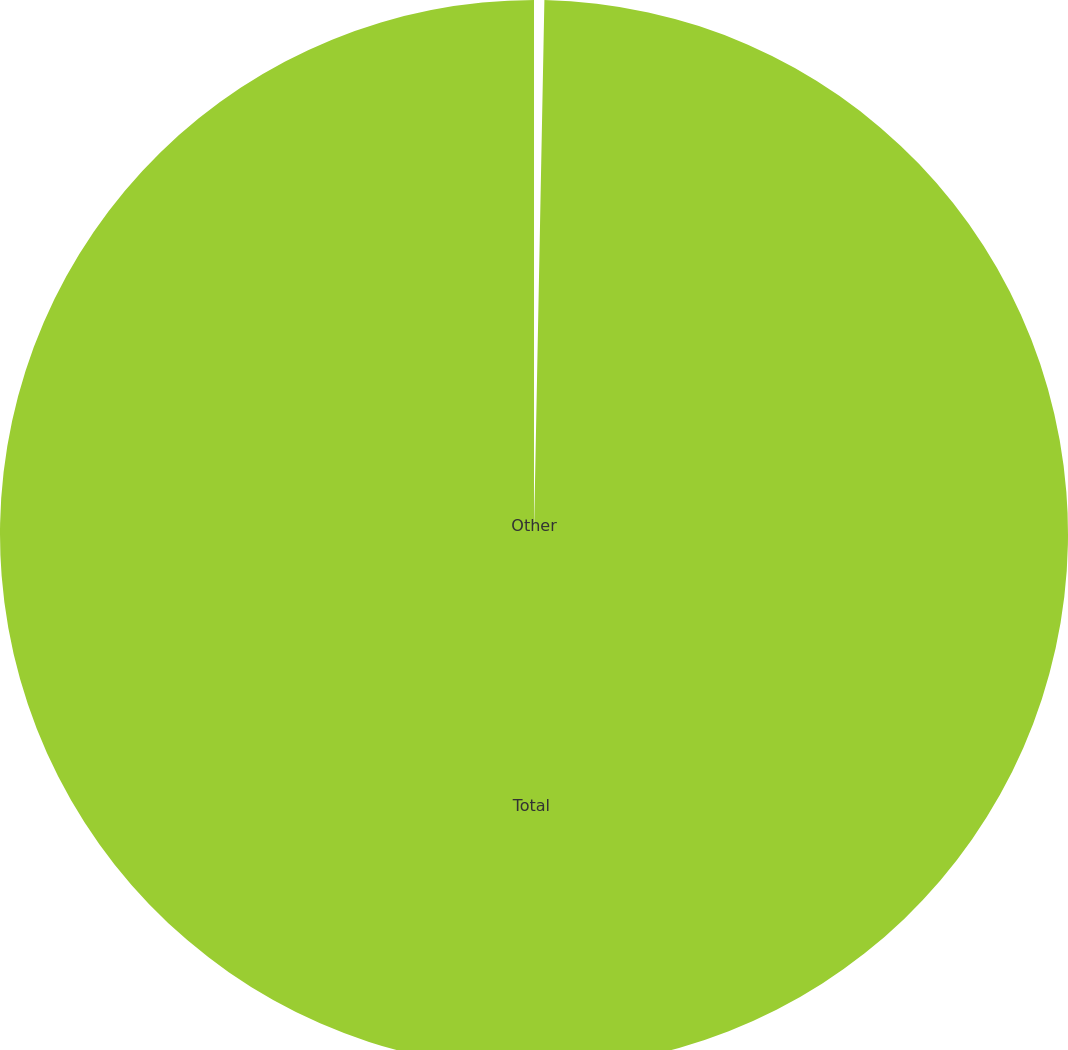Convert chart to OTSL. <chart><loc_0><loc_0><loc_500><loc_500><pie_chart><fcel>Other<fcel>Total<nl><fcel>0.31%<fcel>99.69%<nl></chart> 